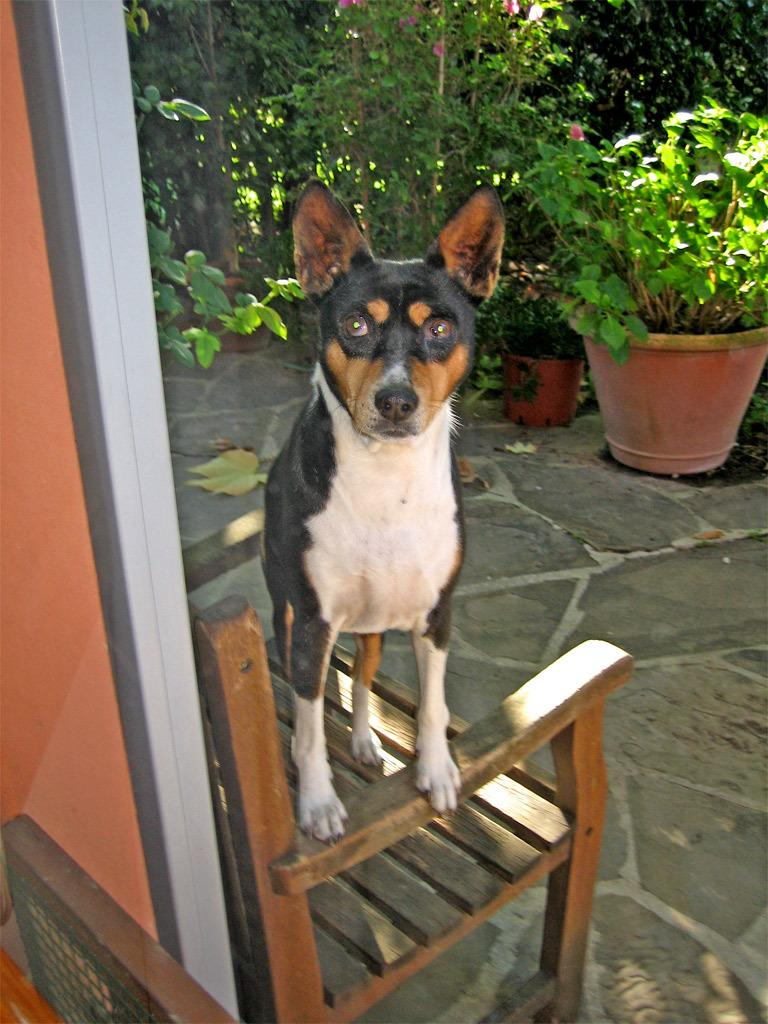What type of animal is in the image? There is a dog in the image. What is the dog doing in the image? The dog is looking at a camera. Where is the dog positioned in the image? The dog is standing on a chair. What else can be seen in the image besides the dog? There are plant pots and plants in the image. What does the dog regret doing in the image? There is no indication in the image that the dog is experiencing regret or any other emotion. 